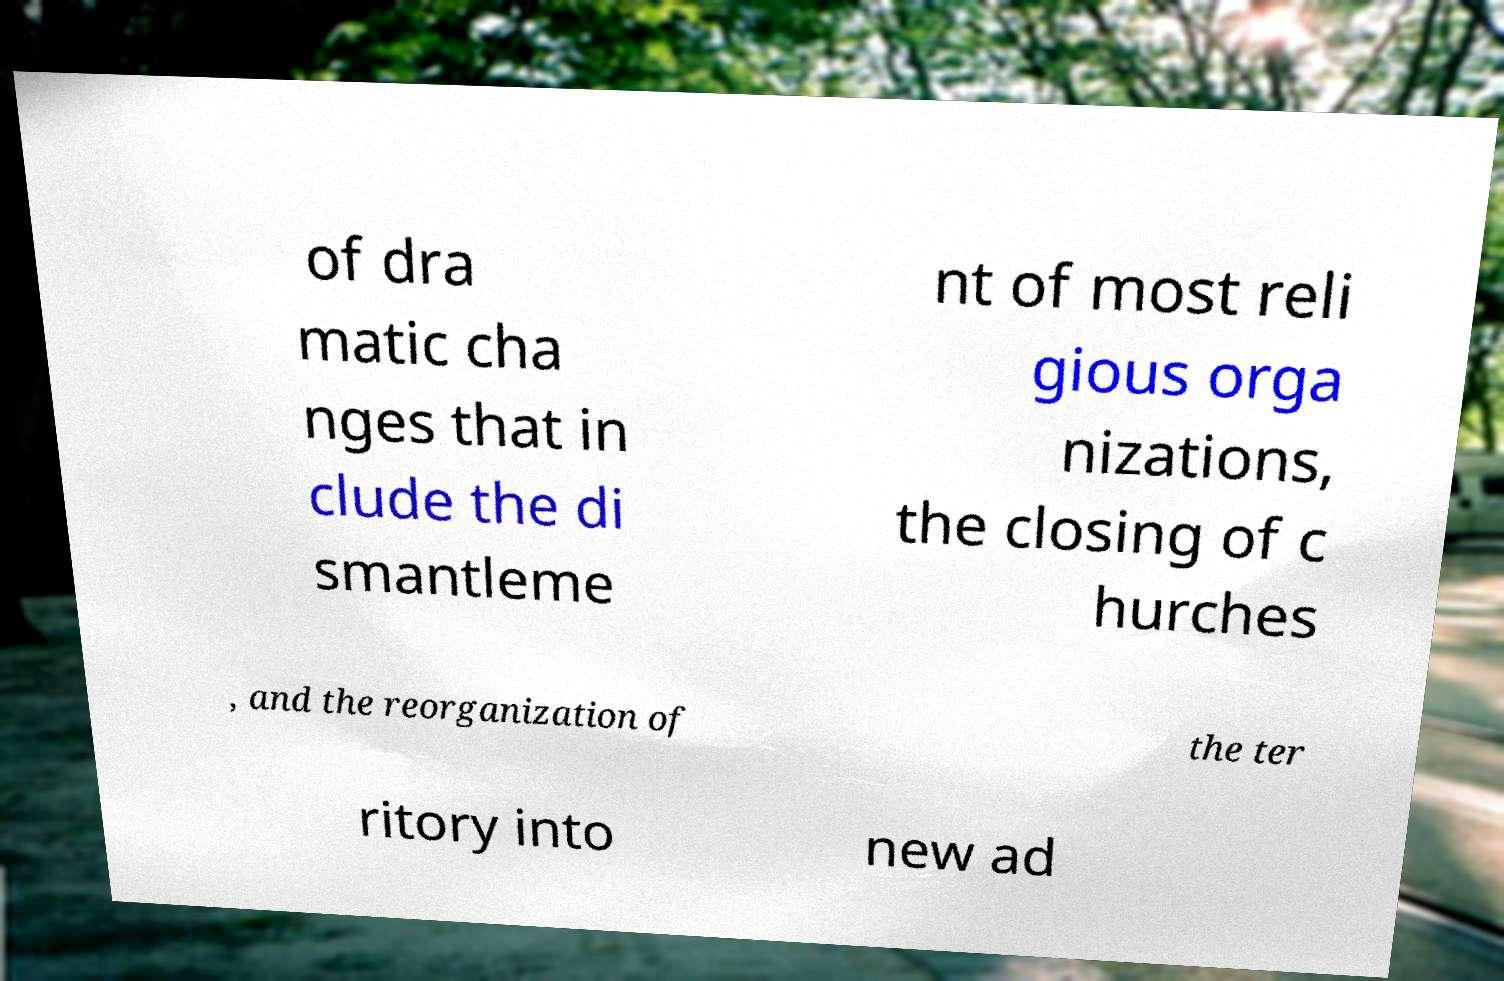Please identify and transcribe the text found in this image. of dra matic cha nges that in clude the di smantleme nt of most reli gious orga nizations, the closing of c hurches , and the reorganization of the ter ritory into new ad 